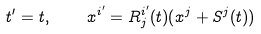<formula> <loc_0><loc_0><loc_500><loc_500>t ^ { \prime } = t , \quad x ^ { i ^ { \prime } } = R ^ { i ^ { \prime } } _ { j } ( t ) ( x ^ { j } + S ^ { j } ( t ) )</formula> 